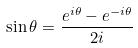Convert formula to latex. <formula><loc_0><loc_0><loc_500><loc_500>\sin \theta = \frac { e ^ { i \theta } - e ^ { - i \theta } } { 2 i }</formula> 